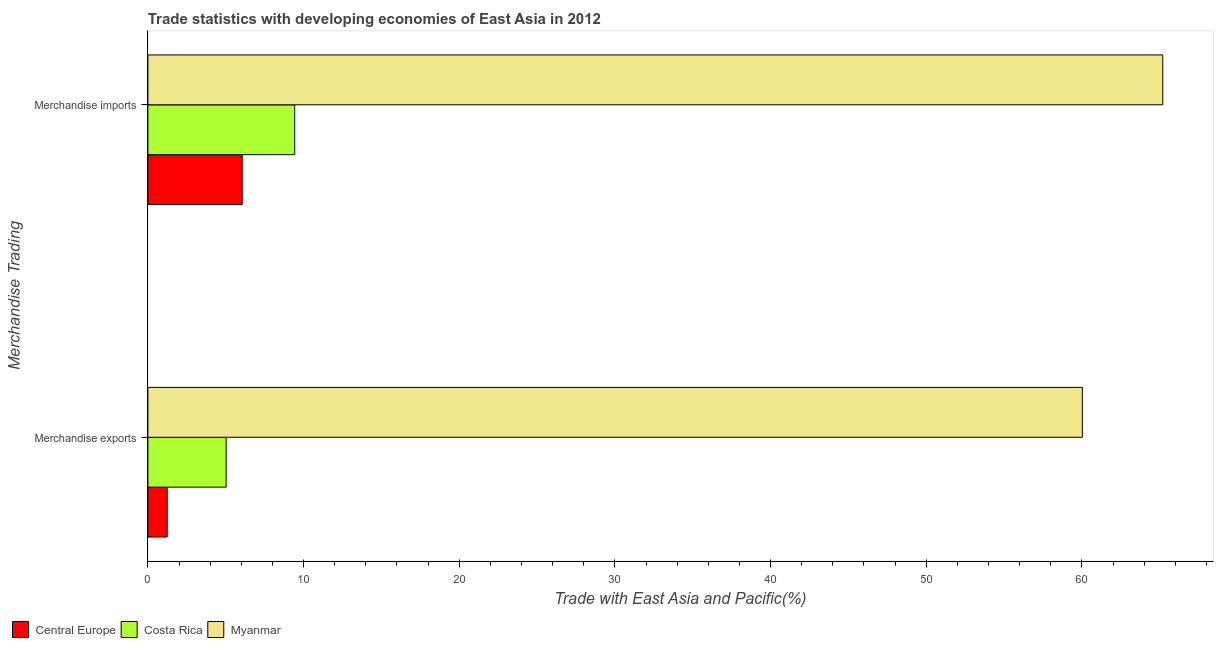How many different coloured bars are there?
Make the answer very short. 3. Are the number of bars per tick equal to the number of legend labels?
Give a very brief answer. Yes. Are the number of bars on each tick of the Y-axis equal?
Your answer should be compact. Yes. What is the label of the 2nd group of bars from the top?
Provide a succinct answer. Merchandise exports. What is the merchandise imports in Costa Rica?
Ensure brevity in your answer.  9.43. Across all countries, what is the maximum merchandise exports?
Make the answer very short. 60.03. Across all countries, what is the minimum merchandise exports?
Keep it short and to the point. 1.24. In which country was the merchandise exports maximum?
Provide a succinct answer. Myanmar. In which country was the merchandise exports minimum?
Give a very brief answer. Central Europe. What is the total merchandise exports in the graph?
Offer a very short reply. 66.3. What is the difference between the merchandise exports in Myanmar and that in Costa Rica?
Make the answer very short. 55. What is the difference between the merchandise exports in Myanmar and the merchandise imports in Costa Rica?
Make the answer very short. 50.6. What is the average merchandise exports per country?
Provide a short and direct response. 22.1. What is the difference between the merchandise imports and merchandise exports in Central Europe?
Provide a short and direct response. 4.82. What is the ratio of the merchandise imports in Costa Rica to that in Myanmar?
Offer a very short reply. 0.14. In how many countries, is the merchandise exports greater than the average merchandise exports taken over all countries?
Your answer should be compact. 1. What does the 3rd bar from the top in Merchandise imports represents?
Your answer should be very brief. Central Europe. What does the 2nd bar from the bottom in Merchandise exports represents?
Your answer should be compact. Costa Rica. How many bars are there?
Offer a very short reply. 6. Are all the bars in the graph horizontal?
Your response must be concise. Yes. How many countries are there in the graph?
Ensure brevity in your answer.  3. Where does the legend appear in the graph?
Your answer should be compact. Bottom left. How many legend labels are there?
Give a very brief answer. 3. How are the legend labels stacked?
Provide a succinct answer. Horizontal. What is the title of the graph?
Keep it short and to the point. Trade statistics with developing economies of East Asia in 2012. Does "Moldova" appear as one of the legend labels in the graph?
Make the answer very short. No. What is the label or title of the X-axis?
Provide a succinct answer. Trade with East Asia and Pacific(%). What is the label or title of the Y-axis?
Give a very brief answer. Merchandise Trading. What is the Trade with East Asia and Pacific(%) of Central Europe in Merchandise exports?
Provide a short and direct response. 1.24. What is the Trade with East Asia and Pacific(%) of Costa Rica in Merchandise exports?
Ensure brevity in your answer.  5.03. What is the Trade with East Asia and Pacific(%) in Myanmar in Merchandise exports?
Make the answer very short. 60.03. What is the Trade with East Asia and Pacific(%) in Central Europe in Merchandise imports?
Your response must be concise. 6.06. What is the Trade with East Asia and Pacific(%) of Costa Rica in Merchandise imports?
Your answer should be very brief. 9.43. What is the Trade with East Asia and Pacific(%) in Myanmar in Merchandise imports?
Provide a short and direct response. 65.19. Across all Merchandise Trading, what is the maximum Trade with East Asia and Pacific(%) in Central Europe?
Provide a succinct answer. 6.06. Across all Merchandise Trading, what is the maximum Trade with East Asia and Pacific(%) in Costa Rica?
Offer a very short reply. 9.43. Across all Merchandise Trading, what is the maximum Trade with East Asia and Pacific(%) in Myanmar?
Provide a short and direct response. 65.19. Across all Merchandise Trading, what is the minimum Trade with East Asia and Pacific(%) of Central Europe?
Offer a very short reply. 1.24. Across all Merchandise Trading, what is the minimum Trade with East Asia and Pacific(%) of Costa Rica?
Your response must be concise. 5.03. Across all Merchandise Trading, what is the minimum Trade with East Asia and Pacific(%) in Myanmar?
Your response must be concise. 60.03. What is the total Trade with East Asia and Pacific(%) in Central Europe in the graph?
Your answer should be very brief. 7.3. What is the total Trade with East Asia and Pacific(%) of Costa Rica in the graph?
Make the answer very short. 14.46. What is the total Trade with East Asia and Pacific(%) in Myanmar in the graph?
Your response must be concise. 125.22. What is the difference between the Trade with East Asia and Pacific(%) of Central Europe in Merchandise exports and that in Merchandise imports?
Give a very brief answer. -4.82. What is the difference between the Trade with East Asia and Pacific(%) of Costa Rica in Merchandise exports and that in Merchandise imports?
Provide a short and direct response. -4.4. What is the difference between the Trade with East Asia and Pacific(%) of Myanmar in Merchandise exports and that in Merchandise imports?
Ensure brevity in your answer.  -5.16. What is the difference between the Trade with East Asia and Pacific(%) of Central Europe in Merchandise exports and the Trade with East Asia and Pacific(%) of Costa Rica in Merchandise imports?
Keep it short and to the point. -8.19. What is the difference between the Trade with East Asia and Pacific(%) in Central Europe in Merchandise exports and the Trade with East Asia and Pacific(%) in Myanmar in Merchandise imports?
Give a very brief answer. -63.95. What is the difference between the Trade with East Asia and Pacific(%) of Costa Rica in Merchandise exports and the Trade with East Asia and Pacific(%) of Myanmar in Merchandise imports?
Ensure brevity in your answer.  -60.16. What is the average Trade with East Asia and Pacific(%) of Central Europe per Merchandise Trading?
Your response must be concise. 3.65. What is the average Trade with East Asia and Pacific(%) in Costa Rica per Merchandise Trading?
Offer a terse response. 7.23. What is the average Trade with East Asia and Pacific(%) of Myanmar per Merchandise Trading?
Your answer should be very brief. 62.61. What is the difference between the Trade with East Asia and Pacific(%) of Central Europe and Trade with East Asia and Pacific(%) of Costa Rica in Merchandise exports?
Ensure brevity in your answer.  -3.79. What is the difference between the Trade with East Asia and Pacific(%) in Central Europe and Trade with East Asia and Pacific(%) in Myanmar in Merchandise exports?
Make the answer very short. -58.79. What is the difference between the Trade with East Asia and Pacific(%) in Costa Rica and Trade with East Asia and Pacific(%) in Myanmar in Merchandise exports?
Provide a short and direct response. -55. What is the difference between the Trade with East Asia and Pacific(%) in Central Europe and Trade with East Asia and Pacific(%) in Costa Rica in Merchandise imports?
Offer a very short reply. -3.38. What is the difference between the Trade with East Asia and Pacific(%) of Central Europe and Trade with East Asia and Pacific(%) of Myanmar in Merchandise imports?
Your response must be concise. -59.14. What is the difference between the Trade with East Asia and Pacific(%) of Costa Rica and Trade with East Asia and Pacific(%) of Myanmar in Merchandise imports?
Offer a terse response. -55.76. What is the ratio of the Trade with East Asia and Pacific(%) in Central Europe in Merchandise exports to that in Merchandise imports?
Offer a terse response. 0.2. What is the ratio of the Trade with East Asia and Pacific(%) of Costa Rica in Merchandise exports to that in Merchandise imports?
Keep it short and to the point. 0.53. What is the ratio of the Trade with East Asia and Pacific(%) of Myanmar in Merchandise exports to that in Merchandise imports?
Make the answer very short. 0.92. What is the difference between the highest and the second highest Trade with East Asia and Pacific(%) in Central Europe?
Provide a short and direct response. 4.82. What is the difference between the highest and the second highest Trade with East Asia and Pacific(%) in Costa Rica?
Offer a very short reply. 4.4. What is the difference between the highest and the second highest Trade with East Asia and Pacific(%) of Myanmar?
Ensure brevity in your answer.  5.16. What is the difference between the highest and the lowest Trade with East Asia and Pacific(%) of Central Europe?
Your response must be concise. 4.82. What is the difference between the highest and the lowest Trade with East Asia and Pacific(%) in Costa Rica?
Keep it short and to the point. 4.4. What is the difference between the highest and the lowest Trade with East Asia and Pacific(%) in Myanmar?
Keep it short and to the point. 5.16. 